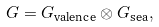Convert formula to latex. <formula><loc_0><loc_0><loc_500><loc_500>G = G _ { \text {valence} } \otimes G _ { \text {sea} } ,</formula> 